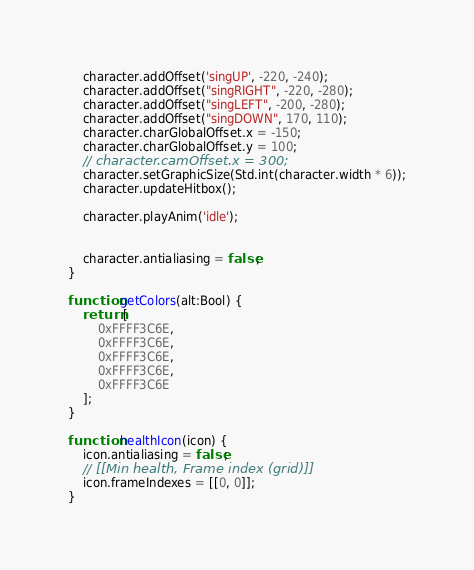<code> <loc_0><loc_0><loc_500><loc_500><_Haxe_>    character.addOffset('singUP', -220, -240);
    character.addOffset("singRIGHT", -220, -280);
    character.addOffset("singLEFT", -200, -280);
    character.addOffset("singDOWN", 170, 110);
    character.charGlobalOffset.x = -150;
    character.charGlobalOffset.y = 100;
    // character.camOffset.x = 300;
    character.setGraphicSize(Std.int(character.width * 6));
    character.updateHitbox();

    character.playAnim('idle');


    character.antialiasing = false;
}

function getColors(alt:Bool) {
    return [
        0xFFFF3C6E,
        0xFFFF3C6E,
        0xFFFF3C6E,
        0xFFFF3C6E,
        0xFFFF3C6E
    ];
}

function healthIcon(icon) {
    icon.antialiasing = false;
    // [[Min health, Frame index (grid)]]
    icon.frameIndexes = [[0, 0]];
}</code> 